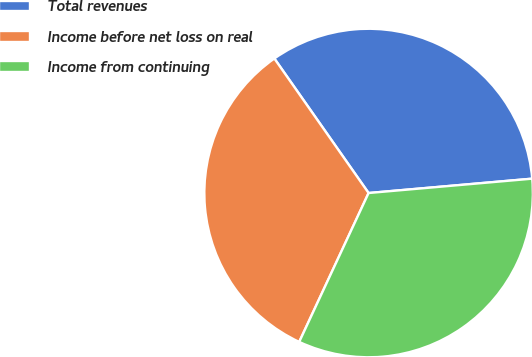Convert chart to OTSL. <chart><loc_0><loc_0><loc_500><loc_500><pie_chart><fcel>Total revenues<fcel>Income before net loss on real<fcel>Income from continuing<nl><fcel>33.33%<fcel>33.33%<fcel>33.33%<nl></chart> 